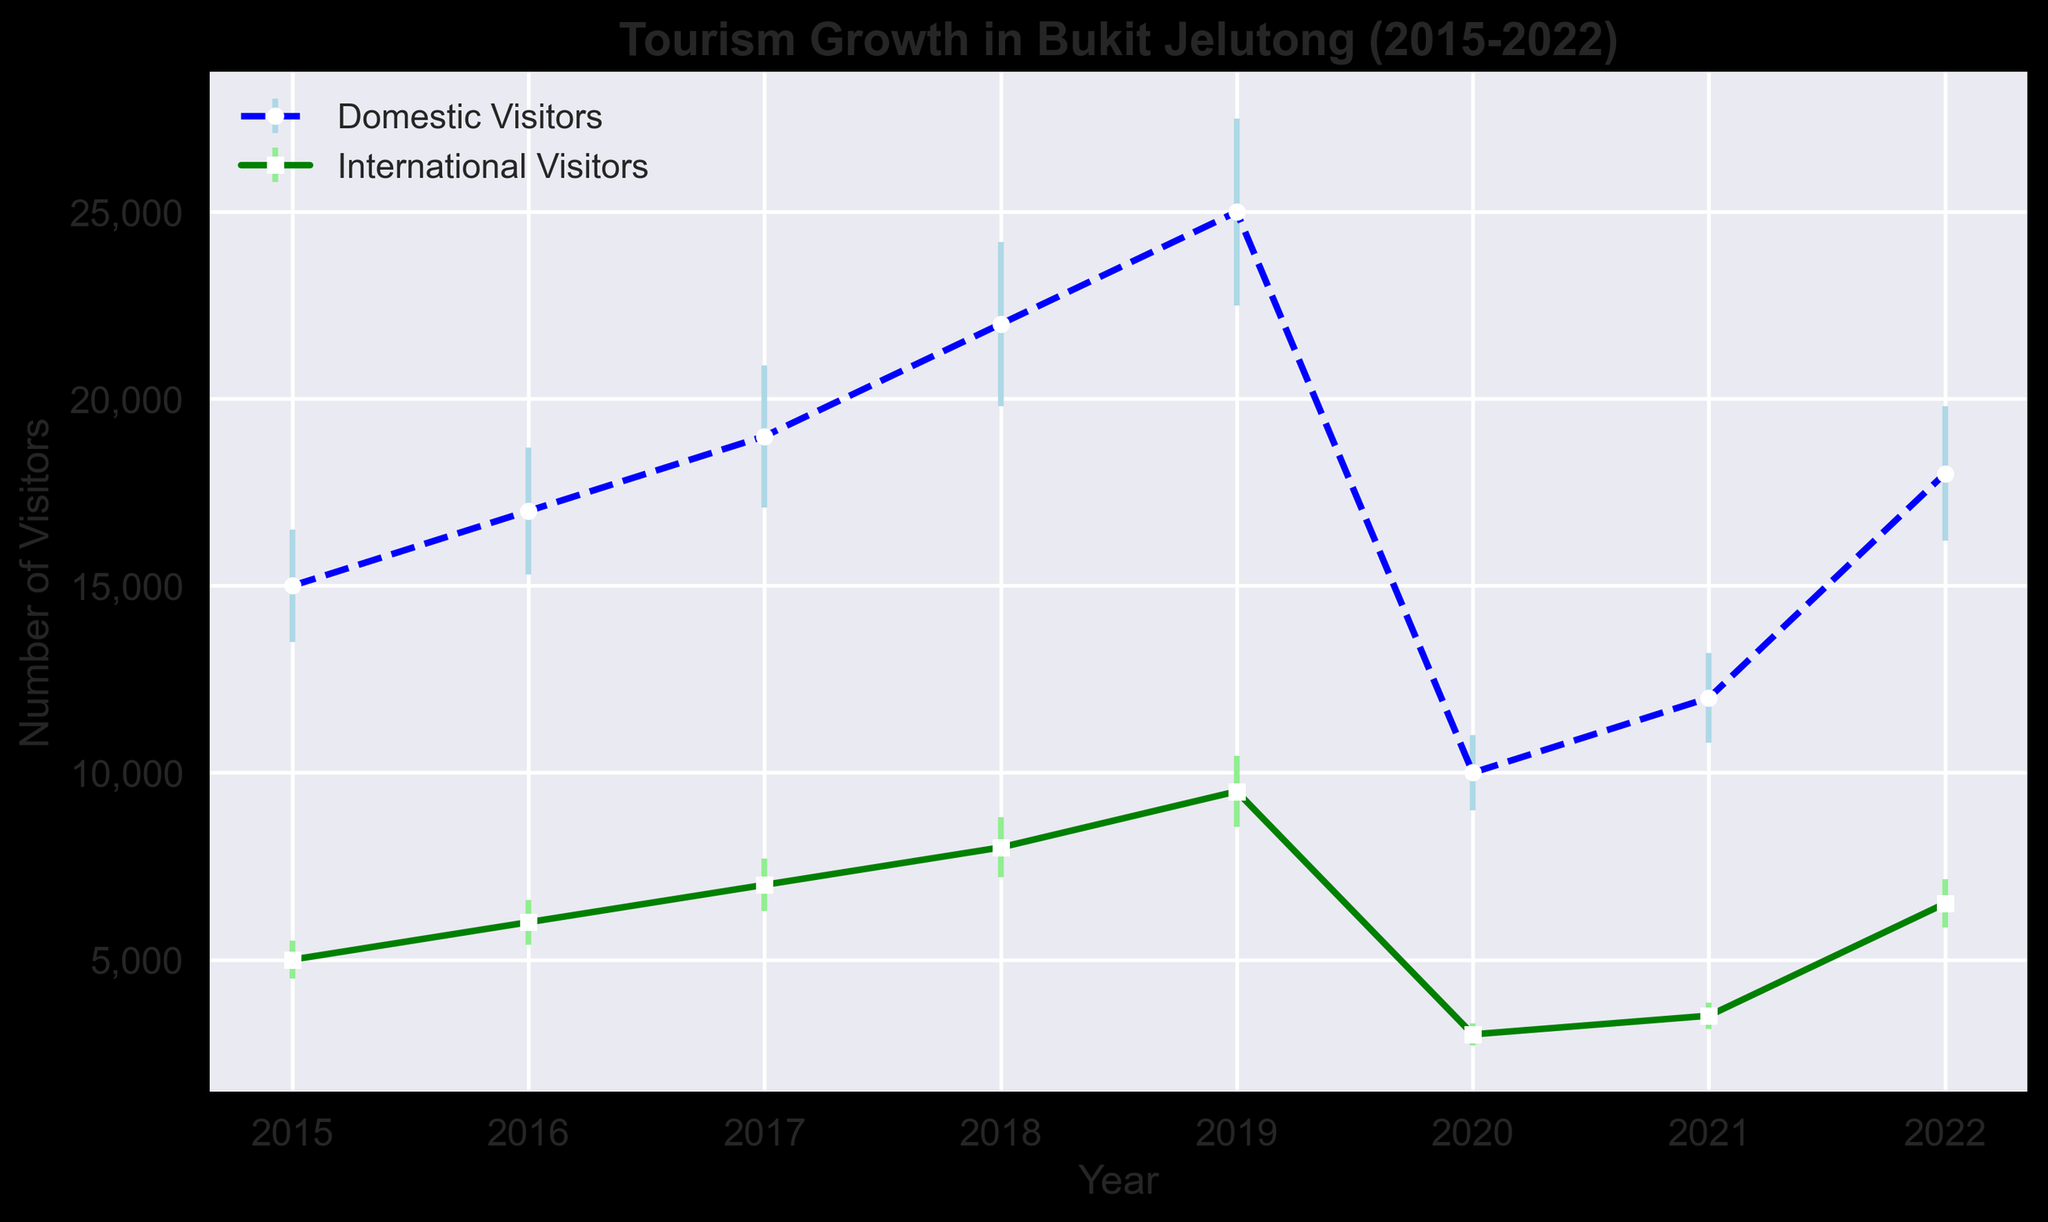What's the overall trend for domestic visitors from 2015 to 2022? To identify the trend, notice the number of domestic visitors each year. From 2015 to 2019, there is a consistent increase in domestic visitors. In 2020, there is a sharp decline, likely due to external factors (e.g., the pandemic). Post-2020, there is a recovery trend with numbers increasing again in 2021 and 2022.
Answer: Increasing until 2019, then decreasing in 2020, followed by recovery in 2021 and 2022 What was the difference in the number of domestic and international visitors in 2018? To find the difference, subtract the number of international visitors from domestic visitors for 2018. The numbers are 22,000 (domestic) and 8,000 (international). So, the difference is 22,000 - 8,000.
Answer: 14,000 Which year had the highest number of international visitors? Scan the international visitors' values across all years. The year 2019 stands out with the highest number of 9,500 international visitors.
Answer: 2019 How much did the number of domestic visitors decrease from 2019 to 2020? Subtract the number of domestic visitors in 2020 from the number in 2019. The numbers are 25,000 (2019) and 10,000 (2020). The decrease is 25,000 - 10,000.
Answer: 15,000 What is the average number of domestic visitors from 2015 to 2017? Add the number of domestic visitors for 2015, 2016, and 2017, then divide by 3. The numbers are 15,000, 17,000, and 19,000. Sum is 15,000 + 17,000 + 19,000 = 51,000. The average is then 51,000 / 3.
Answer: 17,000 Which category, domestic or international visitors, experienced a greater percentage decrease in 2020 compared to 2019? First, find the percentage decrease for each category. For domestic visitors: (25,000 - 10,000) / 25,000 * 100 = 60%. For international visitors: (9,500 - 3,000) / 9,500 * 100 = 68.42%.
Answer: International visitors How did the number of international visitors change from 2021 to 2022? Look at the numbers for 2021 and 2022 for international visitors, which are 3,500 and 6,500, respectively. Subtract 3,500 from 6,500 to find the increase.
Answer: Increased by 3,000 What was the range of domestic visitors across all years? Determine the minimum and maximum number of domestic visitors, 10,000 (2020) and 25,000 (2019). The range is the difference between the maximum and minimum.
Answer: 15,000 Which year experienced the largest annual growth in domestic visitors? Calculate the difference in the number of domestic visitors between consecutive years and identify the largest increase. The largest growth is from 2018 to 2019, increasing by 3,000 (25,000 - 22,000).
Answer: 2019 Do domestic or international visitors have larger error bars on average? Compare the error values. The domestic errors are 1,500, 1,700, 1,900, 2,200, 2,500, 1,000, 1,200, 1,800. The international errors are 500, 600, 700, 800, 950, 300, 350, 650. The average error for domestic visitors is higher on average.
Answer: Domestic visitors 